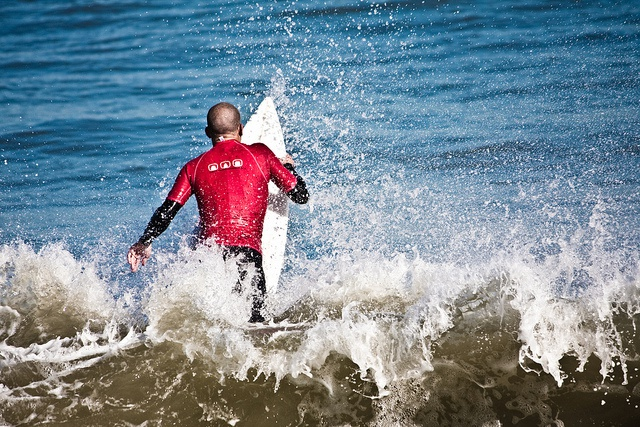Describe the objects in this image and their specific colors. I can see people in blue, lightgray, black, and brown tones and surfboard in blue, white, darkgray, and black tones in this image. 